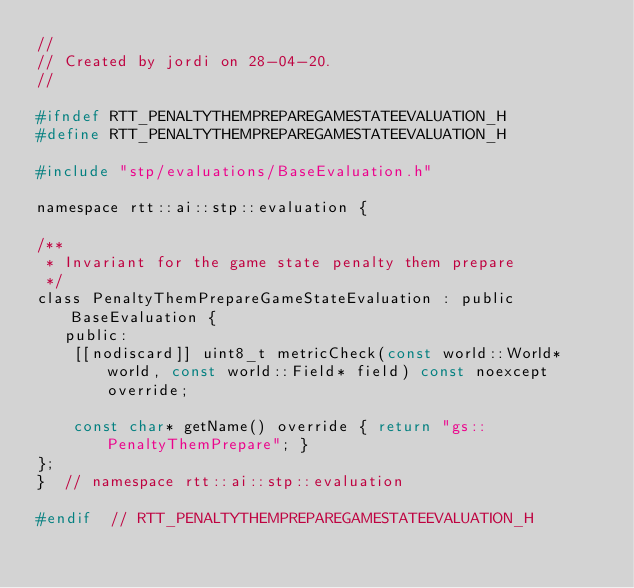<code> <loc_0><loc_0><loc_500><loc_500><_C_>//
// Created by jordi on 28-04-20.
//

#ifndef RTT_PENALTYTHEMPREPAREGAMESTATEEVALUATION_H
#define RTT_PENALTYTHEMPREPAREGAMESTATEEVALUATION_H

#include "stp/evaluations/BaseEvaluation.h"

namespace rtt::ai::stp::evaluation {

/**
 * Invariant for the game state penalty them prepare
 */
class PenaltyThemPrepareGameStateEvaluation : public BaseEvaluation {
   public:
    [[nodiscard]] uint8_t metricCheck(const world::World* world, const world::Field* field) const noexcept override;

    const char* getName() override { return "gs::PenaltyThemPrepare"; }
};
}  // namespace rtt::ai::stp::evaluation

#endif  // RTT_PENALTYTHEMPREPAREGAMESTATEEVALUATION_H
</code> 